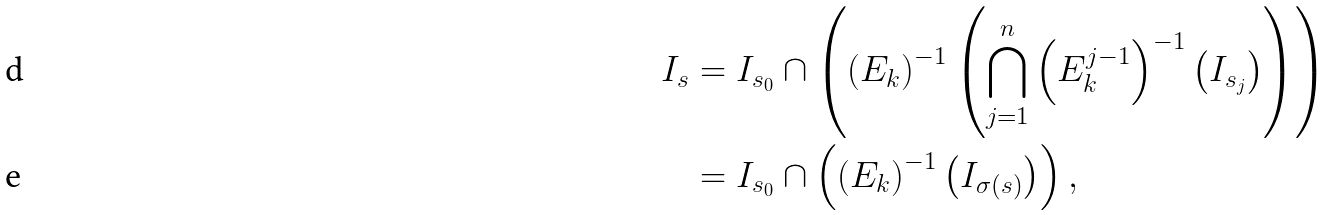Convert formula to latex. <formula><loc_0><loc_0><loc_500><loc_500>I _ { s } & = I _ { s _ { 0 } } \cap \left ( \left ( E _ { k } \right ) ^ { - 1 } \left ( \bigcap _ { j = 1 } ^ { n } \left ( E _ { k } ^ { j - 1 } \right ) ^ { - 1 } \left ( I _ { s _ { j } } \right ) \right ) \right ) \\ & = I _ { s _ { 0 } } \cap \left ( \left ( E _ { k } \right ) ^ { - 1 } \left ( I _ { \sigma ( s ) } \right ) \right ) ,</formula> 